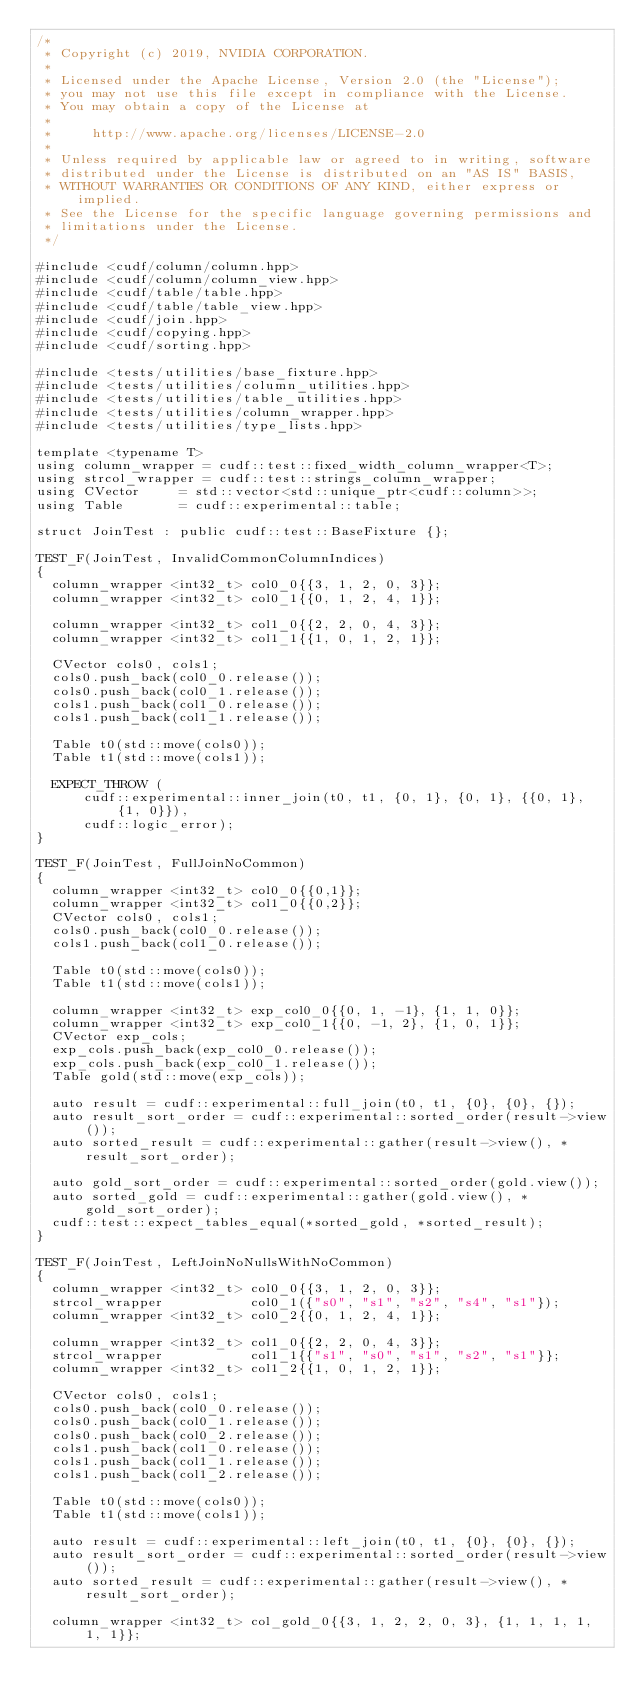Convert code to text. <code><loc_0><loc_0><loc_500><loc_500><_Cuda_>/*
 * Copyright (c) 2019, NVIDIA CORPORATION.
 *
 * Licensed under the Apache License, Version 2.0 (the "License");
 * you may not use this file except in compliance with the License.
 * You may obtain a copy of the License at
 *
 *     http://www.apache.org/licenses/LICENSE-2.0
 *
 * Unless required by applicable law or agreed to in writing, software
 * distributed under the License is distributed on an "AS IS" BASIS,
 * WITHOUT WARRANTIES OR CONDITIONS OF ANY KIND, either express or implied.
 * See the License for the specific language governing permissions and
 * limitations under the License.
 */

#include <cudf/column/column.hpp>
#include <cudf/column/column_view.hpp>
#include <cudf/table/table.hpp>
#include <cudf/table/table_view.hpp>
#include <cudf/join.hpp>
#include <cudf/copying.hpp>
#include <cudf/sorting.hpp>

#include <tests/utilities/base_fixture.hpp>
#include <tests/utilities/column_utilities.hpp>
#include <tests/utilities/table_utilities.hpp>
#include <tests/utilities/column_wrapper.hpp>
#include <tests/utilities/type_lists.hpp>

template <typename T>
using column_wrapper = cudf::test::fixed_width_column_wrapper<T>;
using strcol_wrapper = cudf::test::strings_column_wrapper;
using CVector     = std::vector<std::unique_ptr<cudf::column>>;
using Table       = cudf::experimental::table;

struct JoinTest : public cudf::test::BaseFixture {};

TEST_F(JoinTest, InvalidCommonColumnIndices)
{
  column_wrapper <int32_t> col0_0{{3, 1, 2, 0, 3}};
  column_wrapper <int32_t> col0_1{{0, 1, 2, 4, 1}};

  column_wrapper <int32_t> col1_0{{2, 2, 0, 4, 3}};
  column_wrapper <int32_t> col1_1{{1, 0, 1, 2, 1}};

  CVector cols0, cols1;
  cols0.push_back(col0_0.release());
  cols0.push_back(col0_1.release());
  cols1.push_back(col1_0.release());
  cols1.push_back(col1_1.release());

  Table t0(std::move(cols0));
  Table t1(std::move(cols1));

  EXPECT_THROW (
      cudf::experimental::inner_join(t0, t1, {0, 1}, {0, 1}, {{0, 1}, {1, 0}}),
      cudf::logic_error);
}

TEST_F(JoinTest, FullJoinNoCommon)
{
  column_wrapper <int32_t> col0_0{{0,1}};
  column_wrapper <int32_t> col1_0{{0,2}};
  CVector cols0, cols1;
  cols0.push_back(col0_0.release());
  cols1.push_back(col1_0.release());

  Table t0(std::move(cols0));
  Table t1(std::move(cols1));

  column_wrapper <int32_t> exp_col0_0{{0, 1, -1}, {1, 1, 0}};
  column_wrapper <int32_t> exp_col0_1{{0, -1, 2}, {1, 0, 1}};
  CVector exp_cols;
  exp_cols.push_back(exp_col0_0.release());
  exp_cols.push_back(exp_col0_1.release());
  Table gold(std::move(exp_cols));

  auto result = cudf::experimental::full_join(t0, t1, {0}, {0}, {});
  auto result_sort_order = cudf::experimental::sorted_order(result->view());
  auto sorted_result = cudf::experimental::gather(result->view(), *result_sort_order);

  auto gold_sort_order = cudf::experimental::sorted_order(gold.view());
  auto sorted_gold = cudf::experimental::gather(gold.view(), *gold_sort_order);
  cudf::test::expect_tables_equal(*sorted_gold, *sorted_result);
}

TEST_F(JoinTest, LeftJoinNoNullsWithNoCommon)
{
  column_wrapper <int32_t> col0_0{{3, 1, 2, 0, 3}};
  strcol_wrapper           col0_1({"s0", "s1", "s2", "s4", "s1"});
  column_wrapper <int32_t> col0_2{{0, 1, 2, 4, 1}};

  column_wrapper <int32_t> col1_0{{2, 2, 0, 4, 3}};
  strcol_wrapper           col1_1{{"s1", "s0", "s1", "s2", "s1"}};
  column_wrapper <int32_t> col1_2{{1, 0, 1, 2, 1}};

  CVector cols0, cols1;
  cols0.push_back(col0_0.release());
  cols0.push_back(col0_1.release());
  cols0.push_back(col0_2.release());
  cols1.push_back(col1_0.release());
  cols1.push_back(col1_1.release());
  cols1.push_back(col1_2.release());

  Table t0(std::move(cols0));
  Table t1(std::move(cols1));

  auto result = cudf::experimental::left_join(t0, t1, {0}, {0}, {});
  auto result_sort_order = cudf::experimental::sorted_order(result->view());
  auto sorted_result = cudf::experimental::gather(result->view(), *result_sort_order);

  column_wrapper <int32_t> col_gold_0{{3, 1, 2, 2, 0, 3}, {1, 1, 1, 1, 1, 1}};</code> 